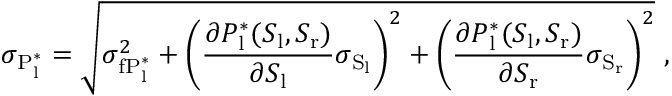Convert formula to latex. <formula><loc_0><loc_0><loc_500><loc_500>\sigma _ { P _ { l } ^ { * } } = \sqrt { \sigma _ { f P _ { l } ^ { * } } ^ { 2 } + \left ( \frac { \partial P _ { l } ^ { * } ( S _ { l } , S _ { r } ) } { \partial S _ { l } } \sigma _ { S _ { l } } \right ) ^ { 2 } + \left ( \frac { \partial P _ { l } ^ { * } ( S _ { l } , S _ { r } ) } { \partial S _ { r } } \sigma _ { S _ { r } } \right ) ^ { 2 } } \ ,</formula> 